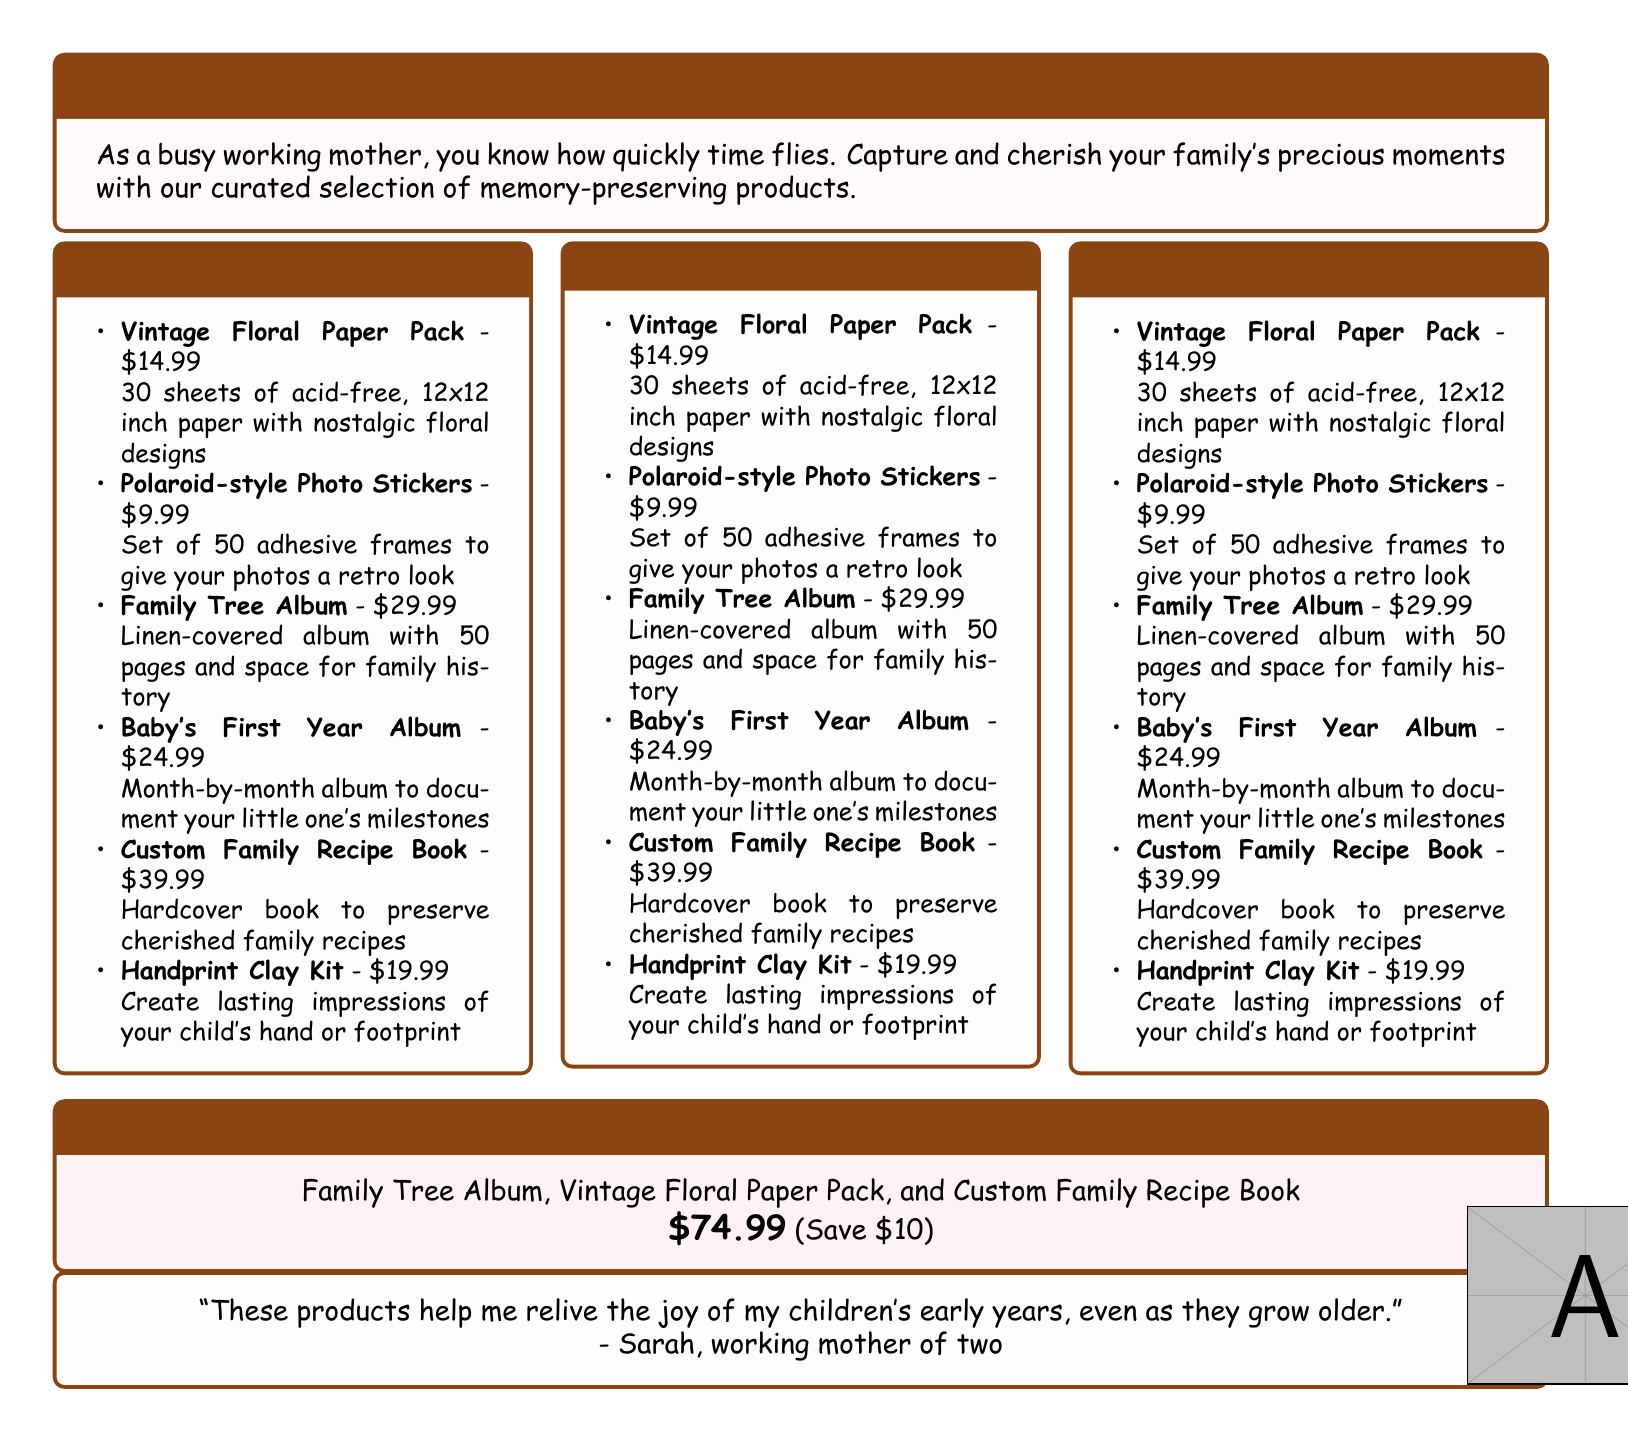what is the price of the Vintage Floral Paper Pack? The price is listed in the document as $14.99.
Answer: $14.99 how many pages does the Family Tree Album have? The document states that the Family Tree Album has 50 pages.
Answer: 50 pages what is included in the Mother's Day Bundle? The document lists Family Tree Album, Vintage Floral Paper Pack, and Custom Family Recipe Book as included items.
Answer: Family Tree Album, Vintage Floral Paper Pack, Custom Family Recipe Book how much do you save with the Mother's Day Bundle? The document indicates that you save $10 with the Mother's Day Bundle.
Answer: $10 what type of album is the Baby's First Year Album? The document describes it as a month-by-month album to document milestones.
Answer: Month-by-month album what is the main purpose of the Custom Family Recipe Book? The document explains that it's to preserve cherished family recipes.
Answer: Preserve cherished family recipes how many adhesive frames are included in the Polaroid-style Photo Stickers? The document mentions that there are 50 adhesive frames included.
Answer: 50 who provided a testimonial about the products? The document attributes the testimonial to Sarah, a working mother of two.
Answer: Sarah 